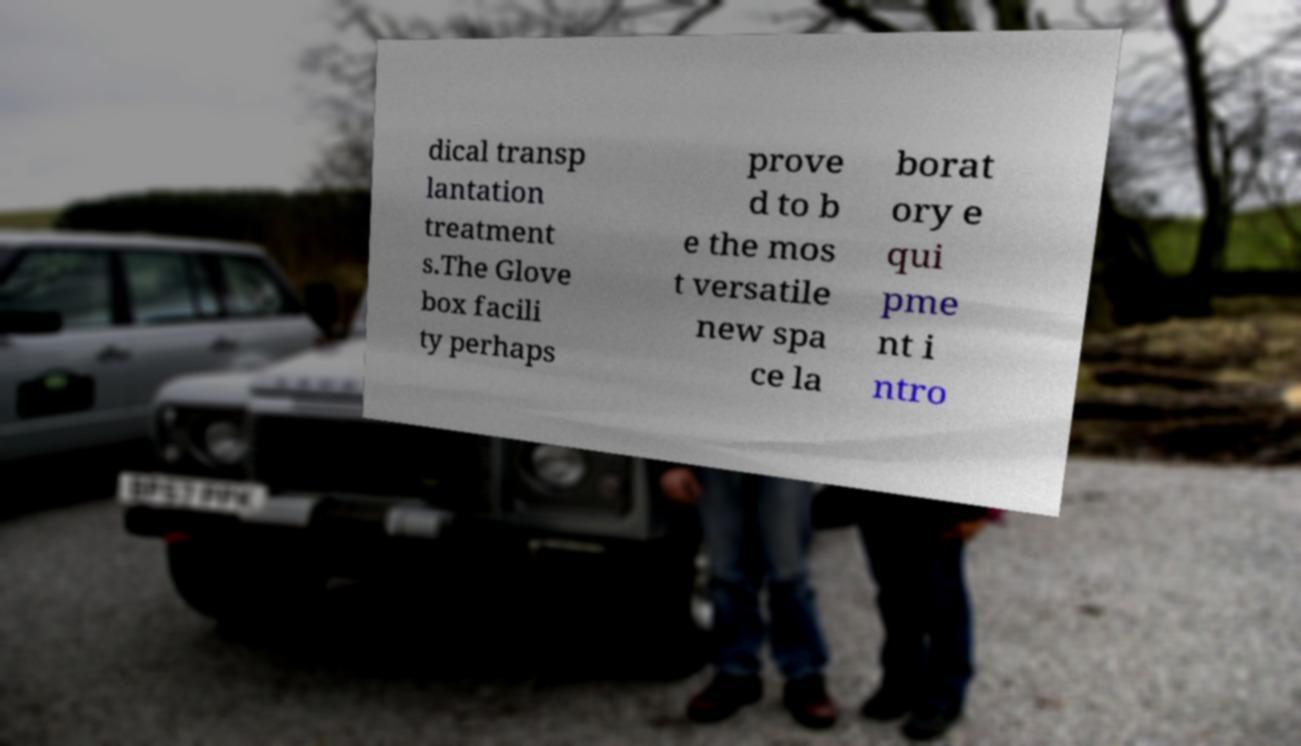For documentation purposes, I need the text within this image transcribed. Could you provide that? dical transp lantation treatment s.The Glove box facili ty perhaps prove d to b e the mos t versatile new spa ce la borat ory e qui pme nt i ntro 